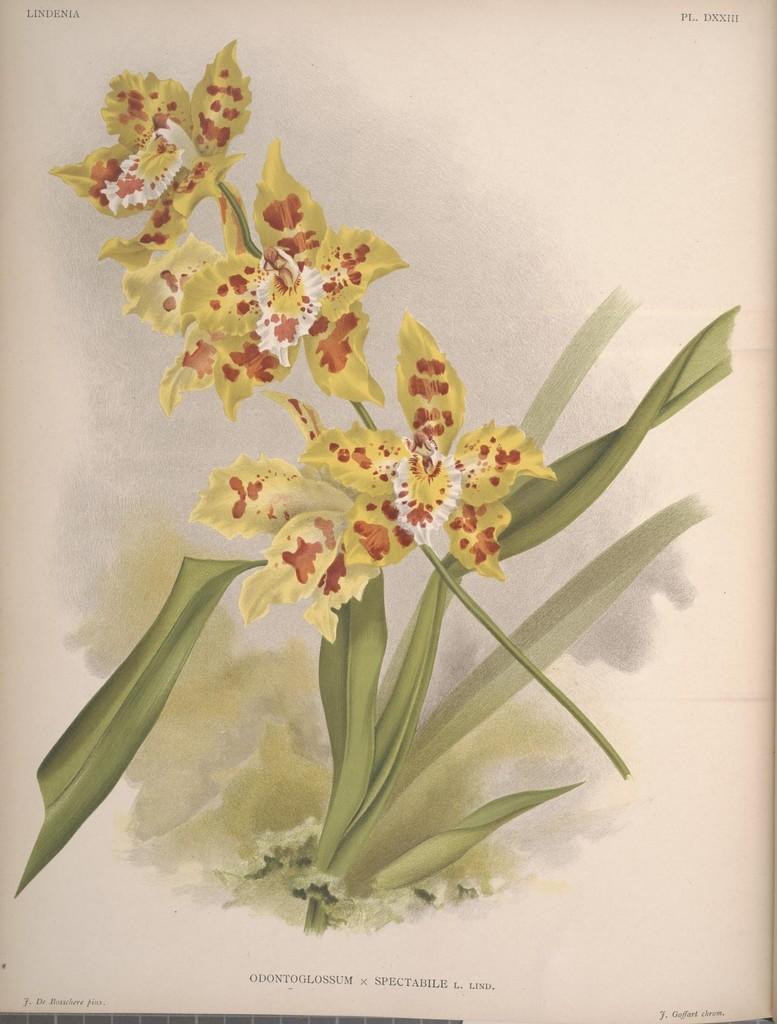Can you describe this image briefly? In this image, we can see a poster. In this poster, there are few flowers with stem and leaves. At the top and bottom of the image, we can see some text. 